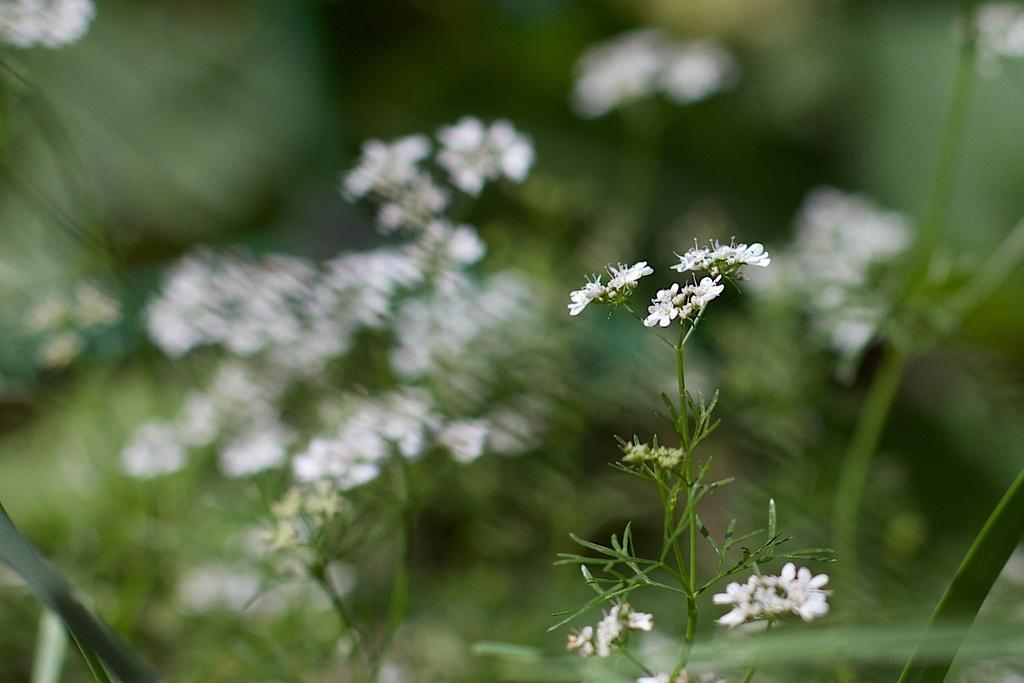What type of plants can be seen in the image? The image contains plants with flowers. Can you describe the flowers on the plants? The flowers present on the plants in the image are not specified, but they are visible. What type of poison is being administered through the stitches in the image? There is no mention of poison or stitches in the image; it only contains plants with flowers. 